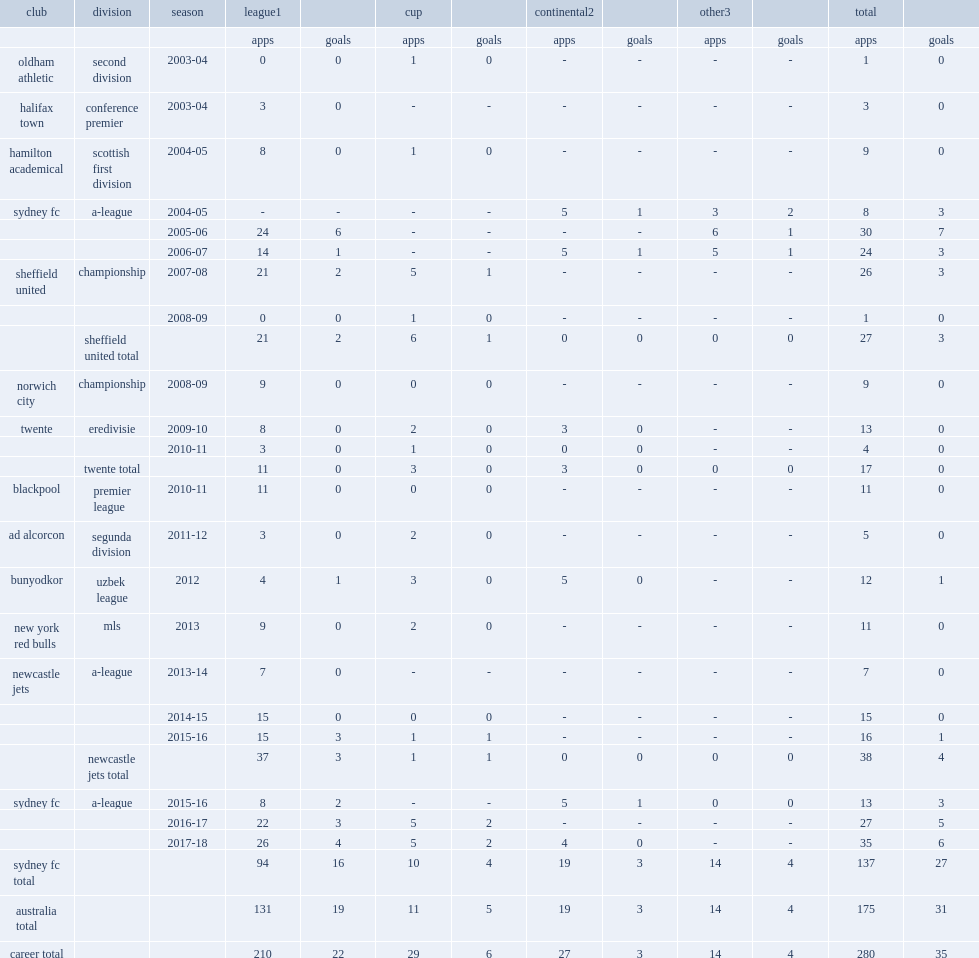When did david carney join uzbek league club bunyodkor? 2012.0. 